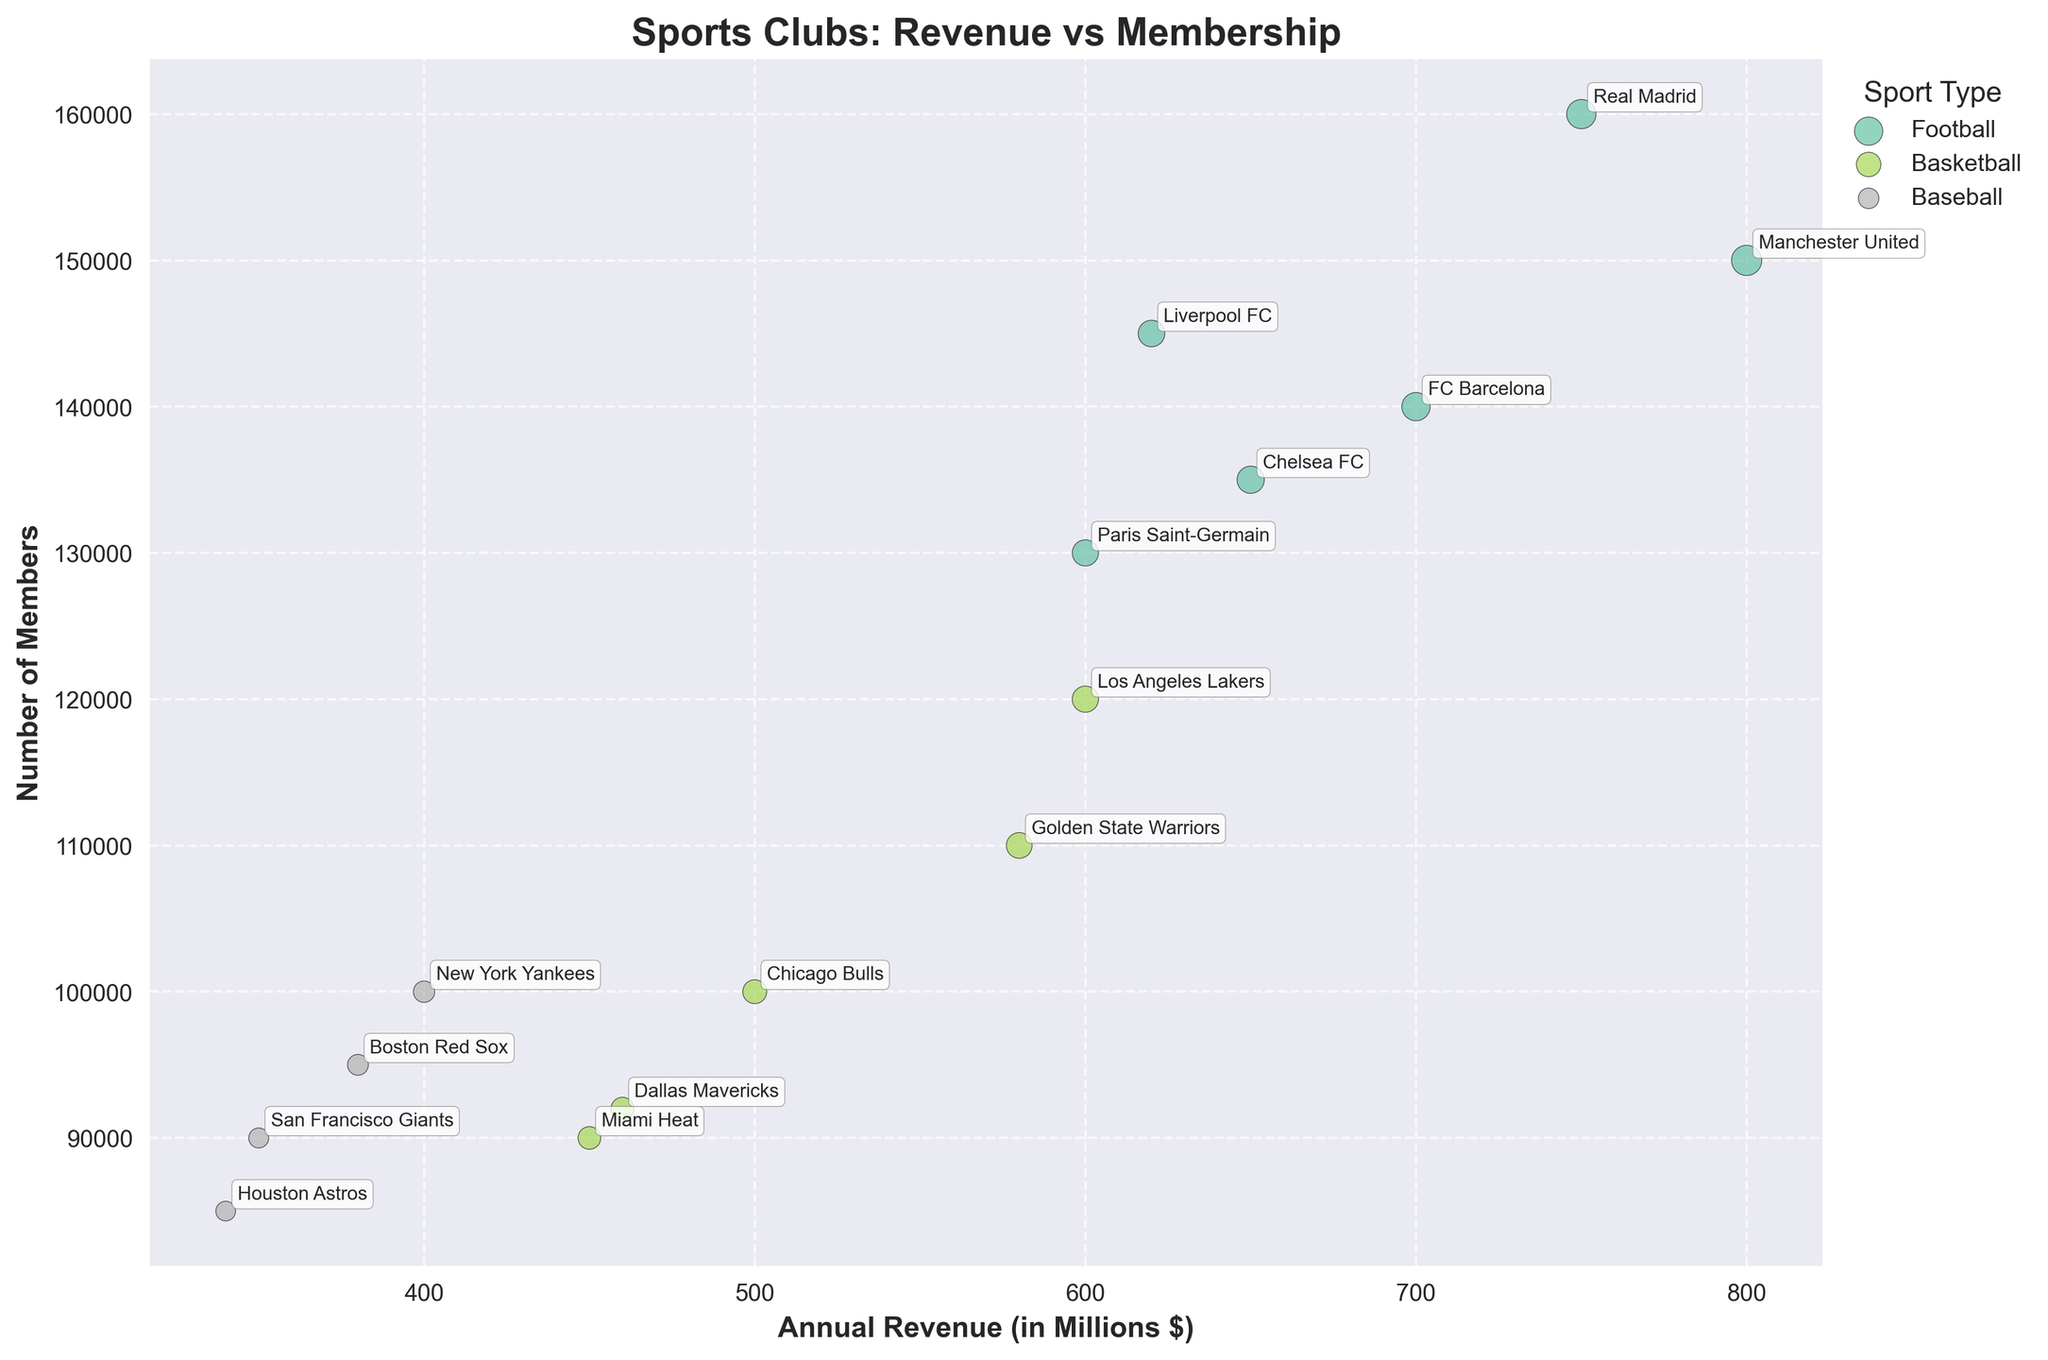What is the title of the chart? The title is located at the top of the chart, generally in bold and larger font size compared to other texts. The title summarizes the content of the chart.
Answer: Sports Clubs: Revenue vs Membership How many sport types are represented in the chart? By counting the distinct groups of points, each denoted by different colors and labeled in the legend, you can determine the number of sport types.
Answer: 3 Which sport club has the highest annual revenue? To find this, identify the data point with the highest position along the x-axis. Looking at the annotated labels helps pinpoint the club.
Answer: Manchester United What is the approximate average annual revenue of football clubs? Calculate the average by summing the annual revenues of all football clubs and dividing by the number of football clubs.
Answer: \$688 million Among the basketball clubs, which one has the highest number of members? Look for the data points grouped by the 'Basketball' label and identify which one is furthest up along the y-axis.
Answer: Los Angeles Lakers Which sport type has the highest median number of members? For each sport type, list the number of members, sort those figures, then find the median. Compare the median values across the sport types.
Answer: Football Which baseball club has the lowest annual revenue, and what is its revenue? Identify the data point furthest to the left within the group labeled 'Baseball.' The annotated label denotes the club name.
Answer: Houston Astros, \$340 million Between the football and basketball clubs, which group shows a greater variation in annual revenue? Calculate the range (maximum - minimum) of annual revenue for both football and basketball clubs and compare.
Answer: Football What is the relationship between the size of the bubble and annual revenue in the chart? Observing that larger bubbles indicate higher annual revenues, you can conclude that the size of the bubble is directly proportional to the annual revenue.
Answer: Directly proportional How does the number of members compare between the highest revenue football club and the highest revenue Basketball club? Compare the y-axis positions of the highest revenue football club (Manchester United) with the highest revenue basketball club (Los Angeles Lakers) to observe the difference in the number of members.
Answer: Manchester United has more members 